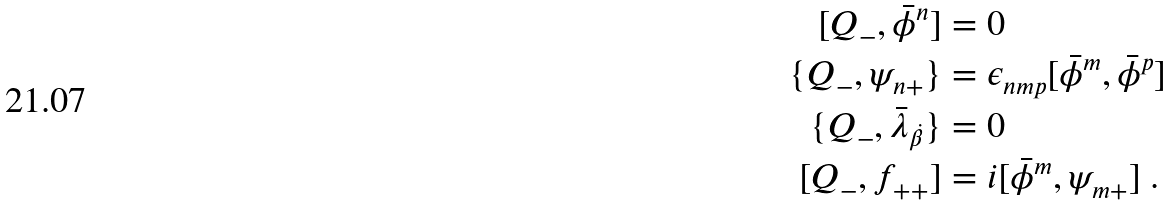<formula> <loc_0><loc_0><loc_500><loc_500>[ Q _ { - } , \bar { \phi } ^ { n } ] & = 0 \\ \{ Q _ { - } , \psi _ { n + } \} & = \epsilon _ { n m p } [ \bar { \phi } ^ { m } , \bar { \phi } ^ { p } ] \\ \{ Q _ { - } , \bar { \lambda } _ { \dot { \beta } } \} & = 0 \\ [ Q _ { - } , f _ { + + } ] & = i [ \bar { \phi } ^ { m } , \psi _ { m + } ] \ .</formula> 